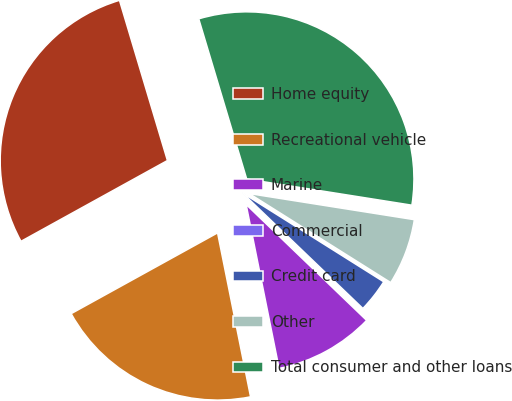<chart> <loc_0><loc_0><loc_500><loc_500><pie_chart><fcel>Home equity<fcel>Recreational vehicle<fcel>Marine<fcel>Commercial<fcel>Credit card<fcel>Other<fcel>Total consumer and other loans<nl><fcel>28.39%<fcel>20.13%<fcel>9.65%<fcel>0.02%<fcel>3.23%<fcel>6.44%<fcel>32.12%<nl></chart> 